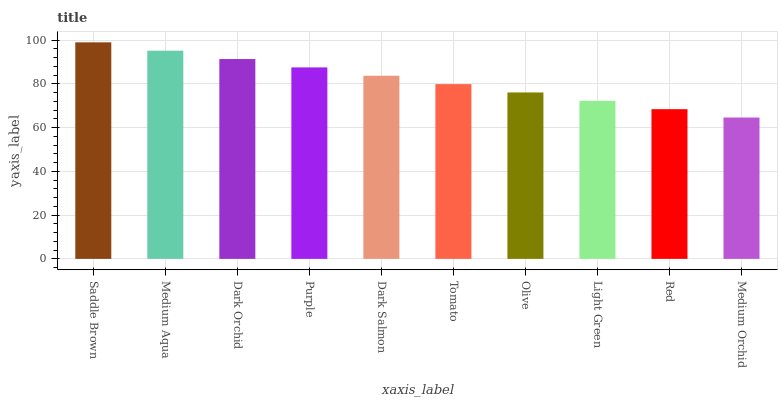Is Medium Orchid the minimum?
Answer yes or no. Yes. Is Saddle Brown the maximum?
Answer yes or no. Yes. Is Medium Aqua the minimum?
Answer yes or no. No. Is Medium Aqua the maximum?
Answer yes or no. No. Is Saddle Brown greater than Medium Aqua?
Answer yes or no. Yes. Is Medium Aqua less than Saddle Brown?
Answer yes or no. Yes. Is Medium Aqua greater than Saddle Brown?
Answer yes or no. No. Is Saddle Brown less than Medium Aqua?
Answer yes or no. No. Is Dark Salmon the high median?
Answer yes or no. Yes. Is Tomato the low median?
Answer yes or no. Yes. Is Red the high median?
Answer yes or no. No. Is Medium Orchid the low median?
Answer yes or no. No. 